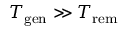Convert formula to latex. <formula><loc_0><loc_0><loc_500><loc_500>T _ { g e n } \gg T _ { r e m }</formula> 